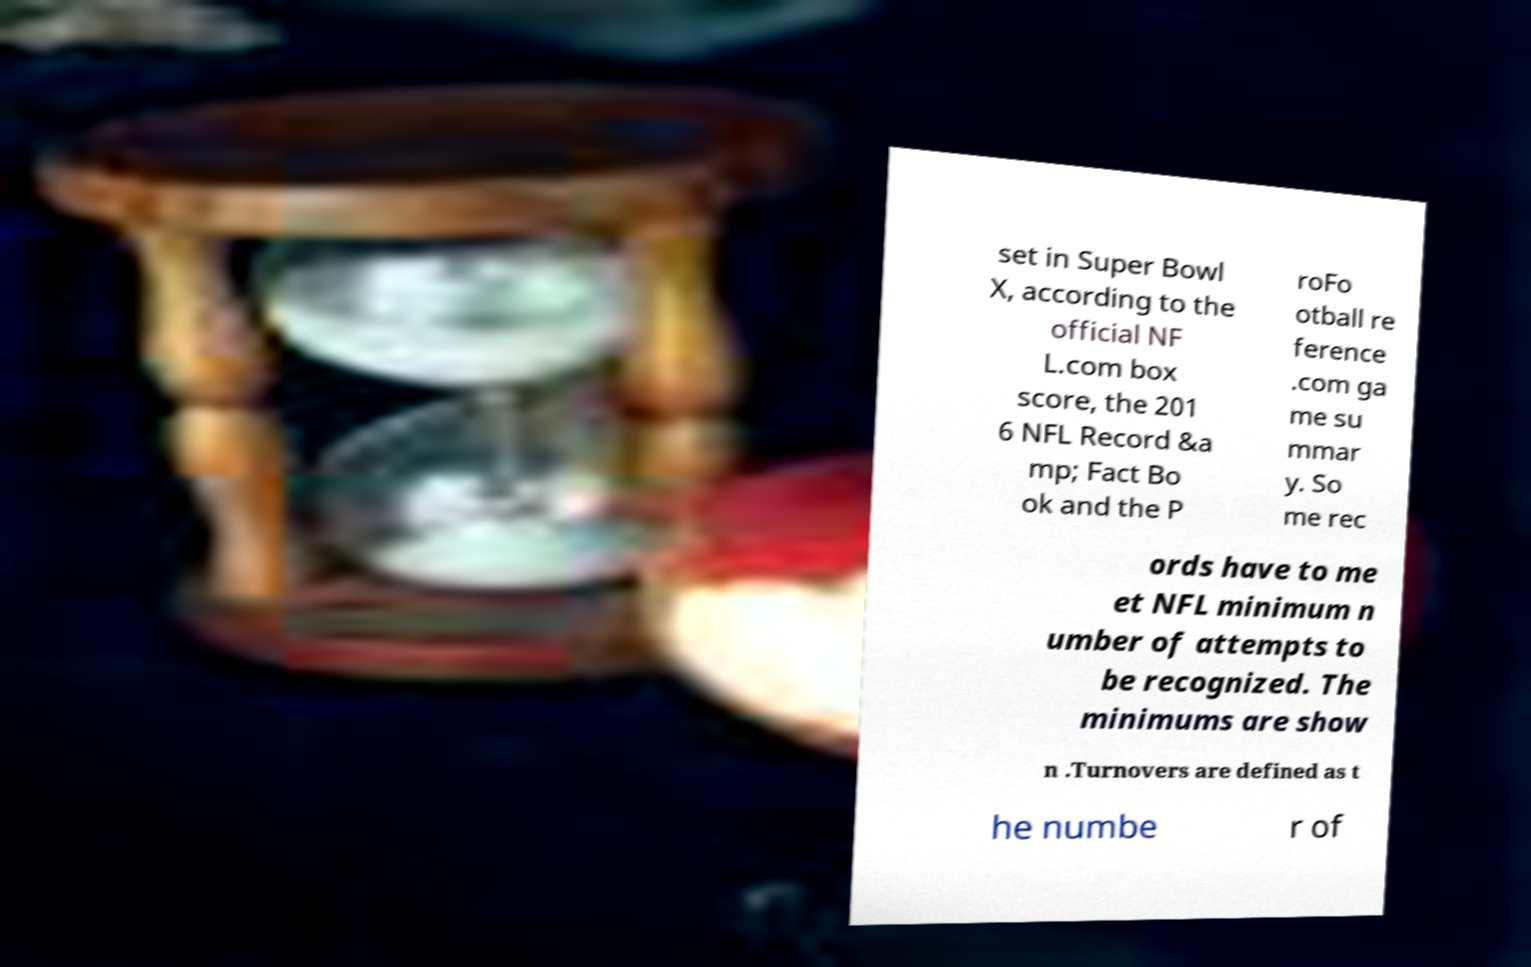There's text embedded in this image that I need extracted. Can you transcribe it verbatim? set in Super Bowl X, according to the official NF L.com box score, the 201 6 NFL Record &a mp; Fact Bo ok and the P roFo otball re ference .com ga me su mmar y. So me rec ords have to me et NFL minimum n umber of attempts to be recognized. The minimums are show n .Turnovers are defined as t he numbe r of 